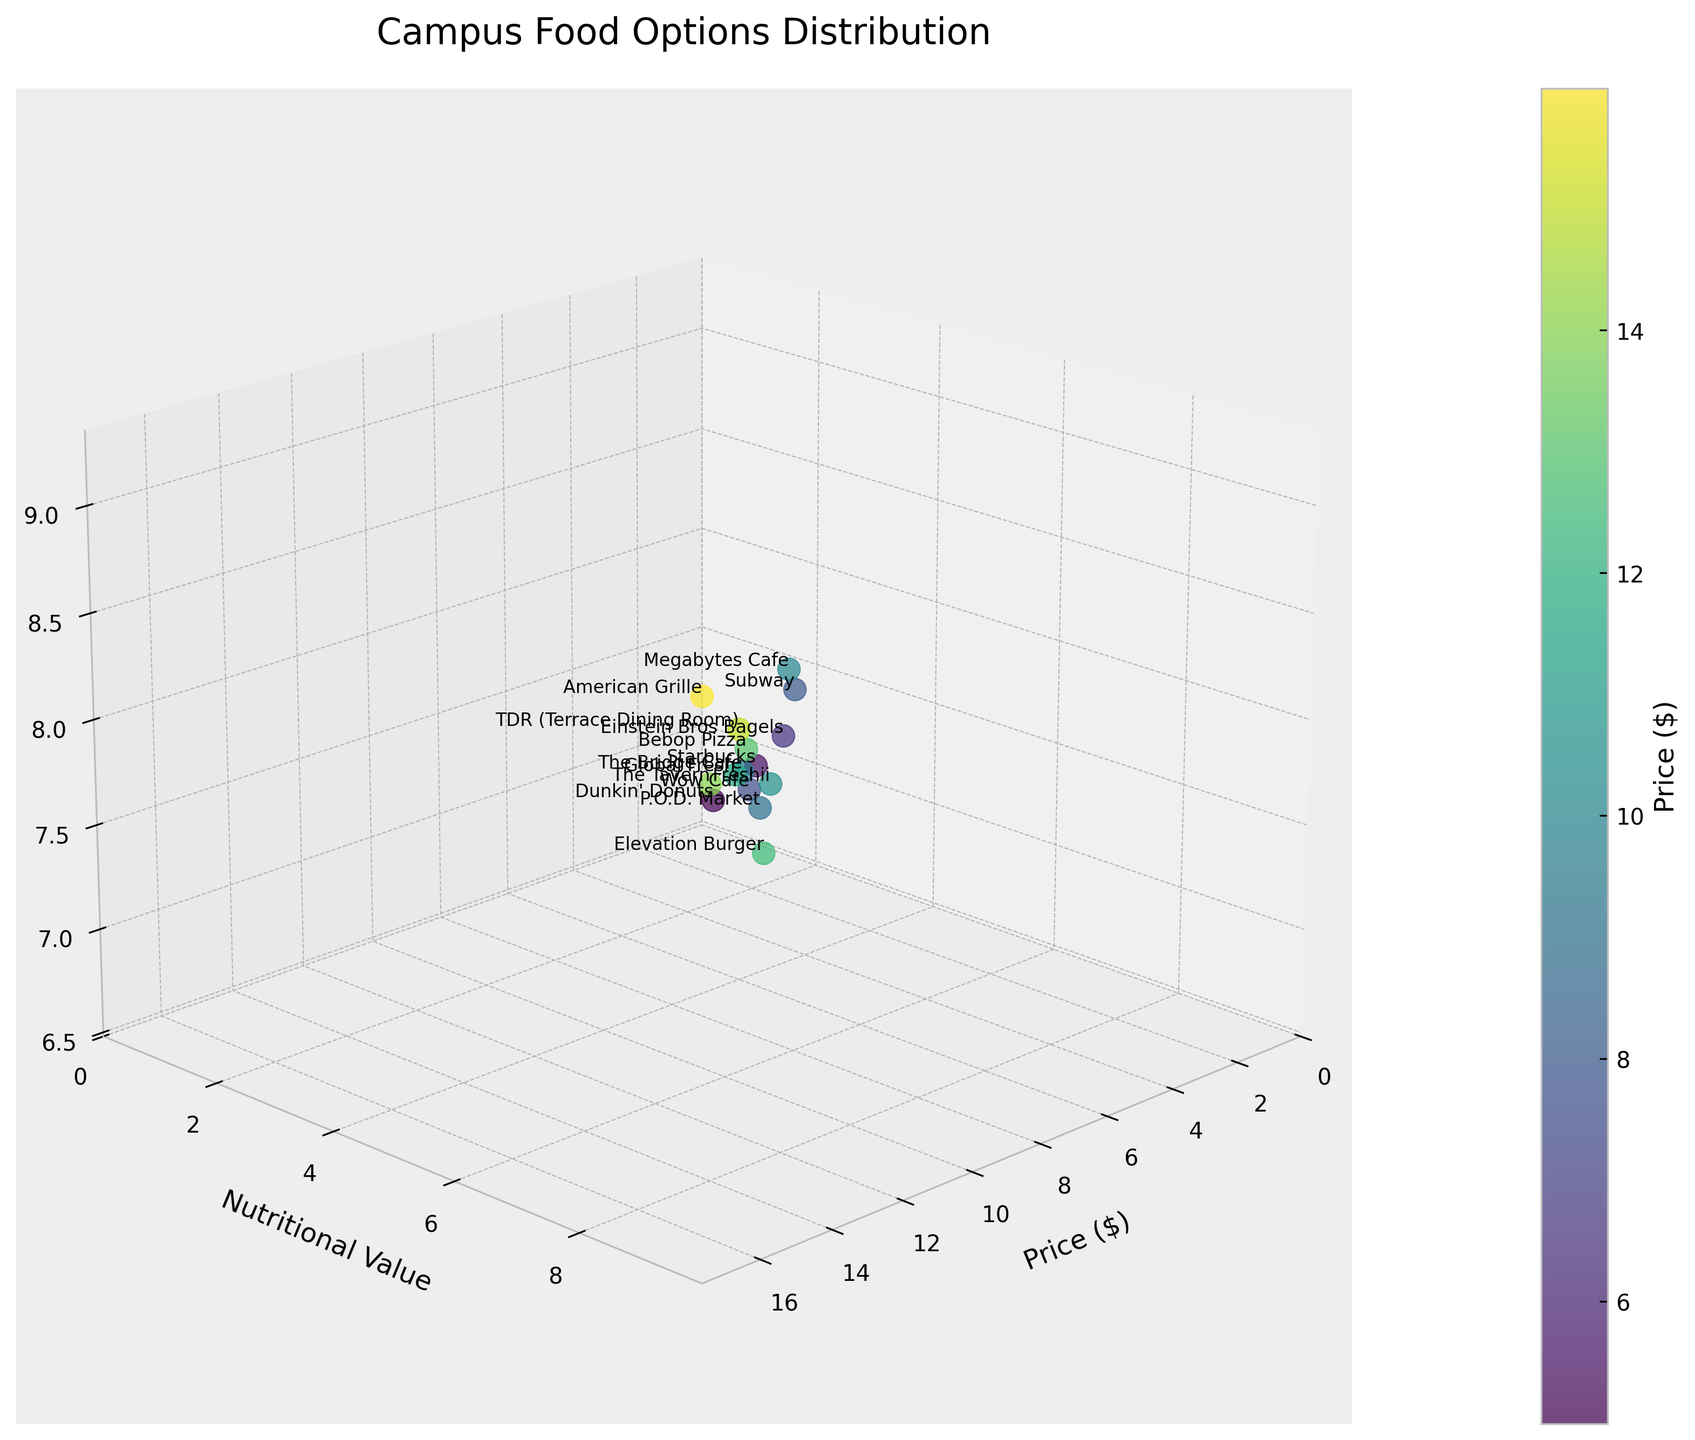What is the title of the plot? The title is displayed at the top of the plot and reads "Campus Food Options Distribution."
Answer: Campus Food Options Distribution How many food options are represented in the plot? The number of data points, which correspond to the number of food options, can be counted visually from the labels on the points. There are 15 labels.
Answer: 15 Which food option has the highest student satisfaction? By looking at the vertical axis (Student Satisfaction) and finding the highest point, which is labeled, we see that "American Grille" has the highest student satisfaction.
Answer: American Grille Which food option has the lowest nutritional value and what is its student satisfaction rate? The lowest value on the nutritional value axis is 3, and the point corresponding to this has the label "Dunkin' Donuts." The student satisfaction rate at this point is 7.2.
Answer: Dunkin' Donuts, 7.2 What is the range of prices for the campus food options? The price axis (horizontal) ranges from the lowest priced option at $4.99 to the highest priced option at $15.99.
Answer: $4.99 to $15.99 Which food option has the highest nutritional value? By identifying the highest value on the nutritional value axis (9) and checking the corresponding label, we find that both "TDR (Terrace Dining Room)" and "American Grille" share this value.
Answer: TDR (Terrace Dining Room), American Grille Which food option has the lowest price, and what is its nutritional value? The lowest price is $4.99, and the label at this point is "Dunkin' Donuts." The nutritional value at this point is 3.
Answer: Dunkin' Donuts, 3 What is the average student satisfaction of food options with a nutritional value of 8? The food options with a nutritional value of 8 are "Elevation Burger," "The Tavern," and "Bebop Pizza." Their student satisfaction rates are 7.9, 8.3, and 8.4 respectively. The average is (7.9 + 8.3 + 8.4) / 3 = 8.2.
Answer: 8.2 Which food option has the highest price among those with a student satisfaction rate above 8? We first filter the points with a student satisfaction rate above 8. The food options that qualify are "Subway," "Megabytes Cafe," "TDR (Terrace Dining Room)," "The Tavern," "Bebop Pizza," and "American Grille." Among these, "American Grille" has the highest price at $15.99.
Answer: American Grille How does the nutritional value of "Megabytes Cafe" compare with "Freshii"? "Megabytes Cafe" has a nutritional value of 7, whereas "Freshii" also has a nutritional value of 7. This indicates that their nutritional values are equal.
Answer: Equal 